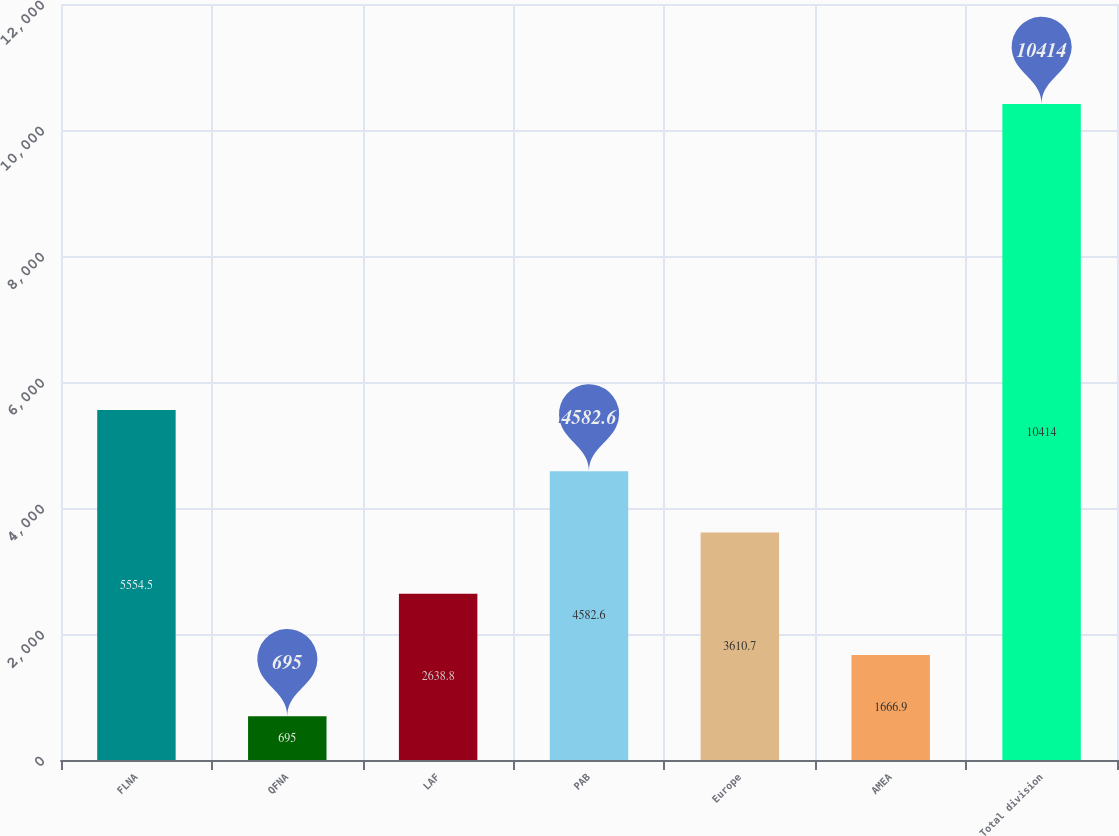Convert chart to OTSL. <chart><loc_0><loc_0><loc_500><loc_500><bar_chart><fcel>FLNA<fcel>QFNA<fcel>LAF<fcel>PAB<fcel>Europe<fcel>AMEA<fcel>Total division<nl><fcel>5554.5<fcel>695<fcel>2638.8<fcel>4582.6<fcel>3610.7<fcel>1666.9<fcel>10414<nl></chart> 